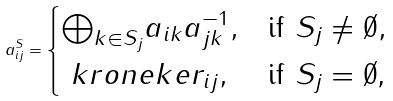Convert formula to latex. <formula><loc_0><loc_0><loc_500><loc_500>a ^ { S } _ { i j } = \begin{cases} { \bigoplus _ { k \in S _ { j } } } a _ { i k } a _ { j k } ^ { - 1 } , & \text {if $S_{j}\ne\emptyset$} , \\ \ k r o n e k e r _ { i j } , & \text {if $S_{j}=\emptyset$,} \end{cases}</formula> 